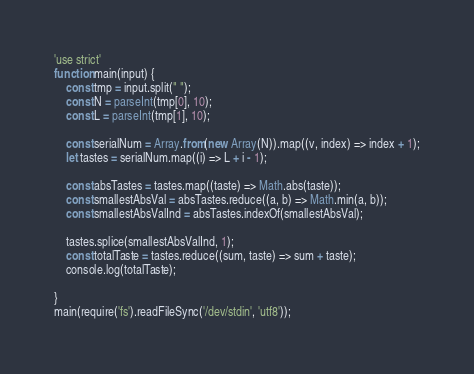<code> <loc_0><loc_0><loc_500><loc_500><_JavaScript_>'use strict'
function main(input) {
    const tmp = input.split(" ");
    const N = parseInt(tmp[0], 10);
    const L = parseInt(tmp[1], 10);

    const serialNum = Array.from(new Array(N)).map((v, index) => index + 1);
    let tastes = serialNum.map((i) => L + i - 1);

    const absTastes = tastes.map((taste) => Math.abs(taste));
    const smallestAbsVal = absTastes.reduce((a, b) => Math.min(a, b));
    const smallestAbsValInd = absTastes.indexOf(smallestAbsVal);

    tastes.splice(smallestAbsValInd, 1);
    const totalTaste = tastes.reduce((sum, taste) => sum + taste);
    console.log(totalTaste);

}
main(require('fs').readFileSync('/dev/stdin', 'utf8'));</code> 